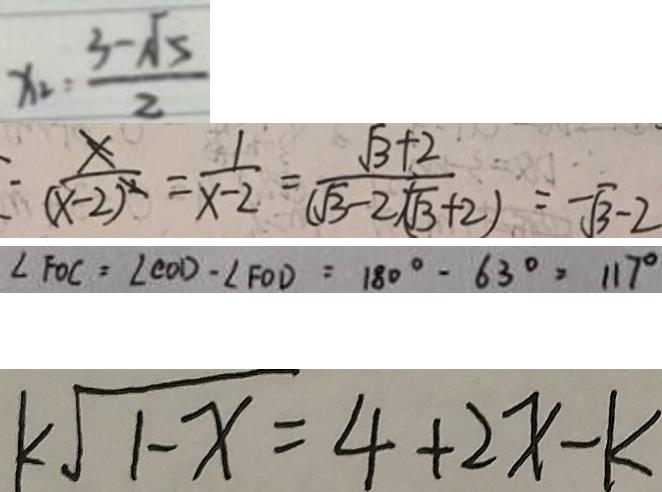Convert formula to latex. <formula><loc_0><loc_0><loc_500><loc_500>x _ { 2 } = \frac { 3 - \sqrt { 5 } } { 2 } 
 \frac { x } { ( x - 2 ) ^ { 2 } } = \frac { 1 } { x - 2 } = \frac { \sqrt { 3 } + 2 } { ( \sqrt { 3 } - 2 \sqrt { 3 } + 2 ) } = - \sqrt { 3 } - 2 
 \angle F O C = \angle C O D - \angle F O D = 1 8 0 ^ { \circ } - 6 3 ^ { \circ } = 1 1 7 ^ { \circ } 
 k \sqrt { 1 - x } = 4 + 2 x - k</formula> 